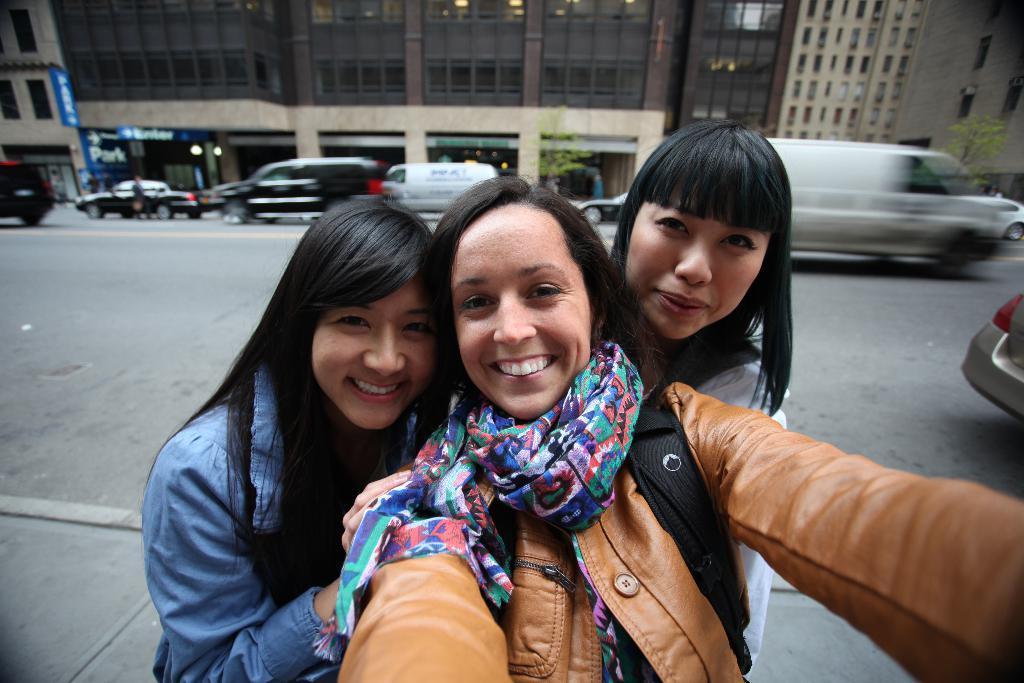Please provide a concise description of this image. In this image there are three girl taking the selfie. In the background there is a road on which there are vehicles. Behind the road there are buildings with the glass windows. 